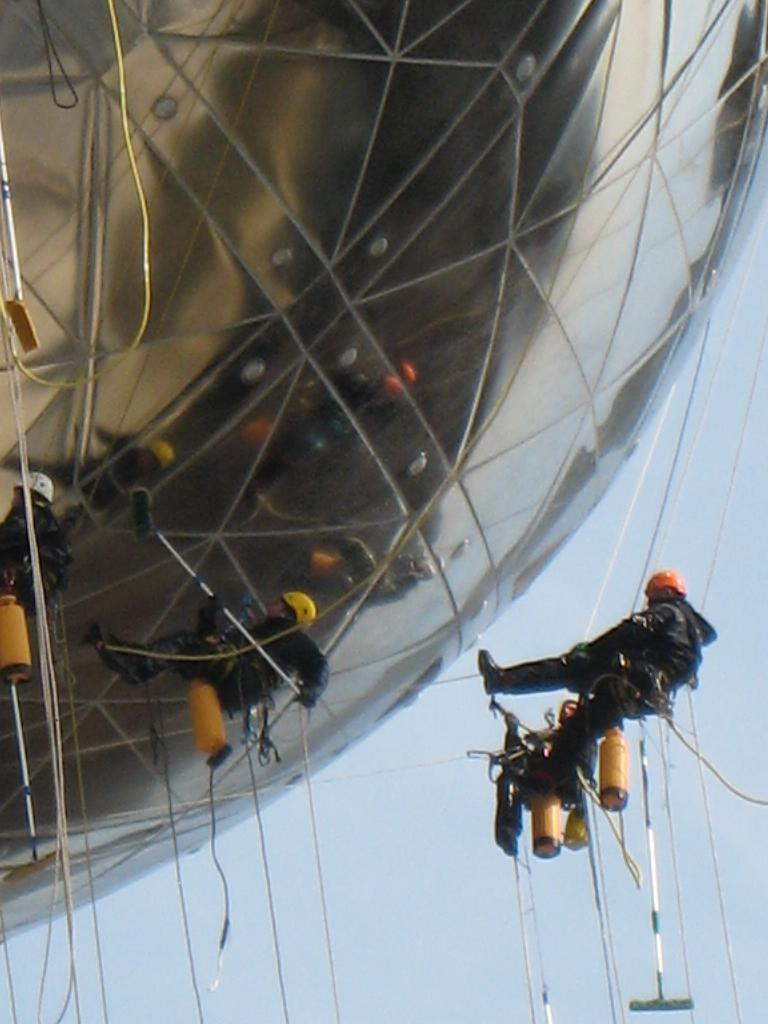What structure is located on the left side of the image? There is a building on the left side of the image. What else can be seen in the image besides the building? There are people in the image. What are the people doing in the image? The people are carrying objects in the image. What can be inferred about the objects the people are carrying? The objects appear to be used for cleaning. What type of smell can be detected from the edge of the image? There is no information about smells in the image, so it cannot be determined from the image. 